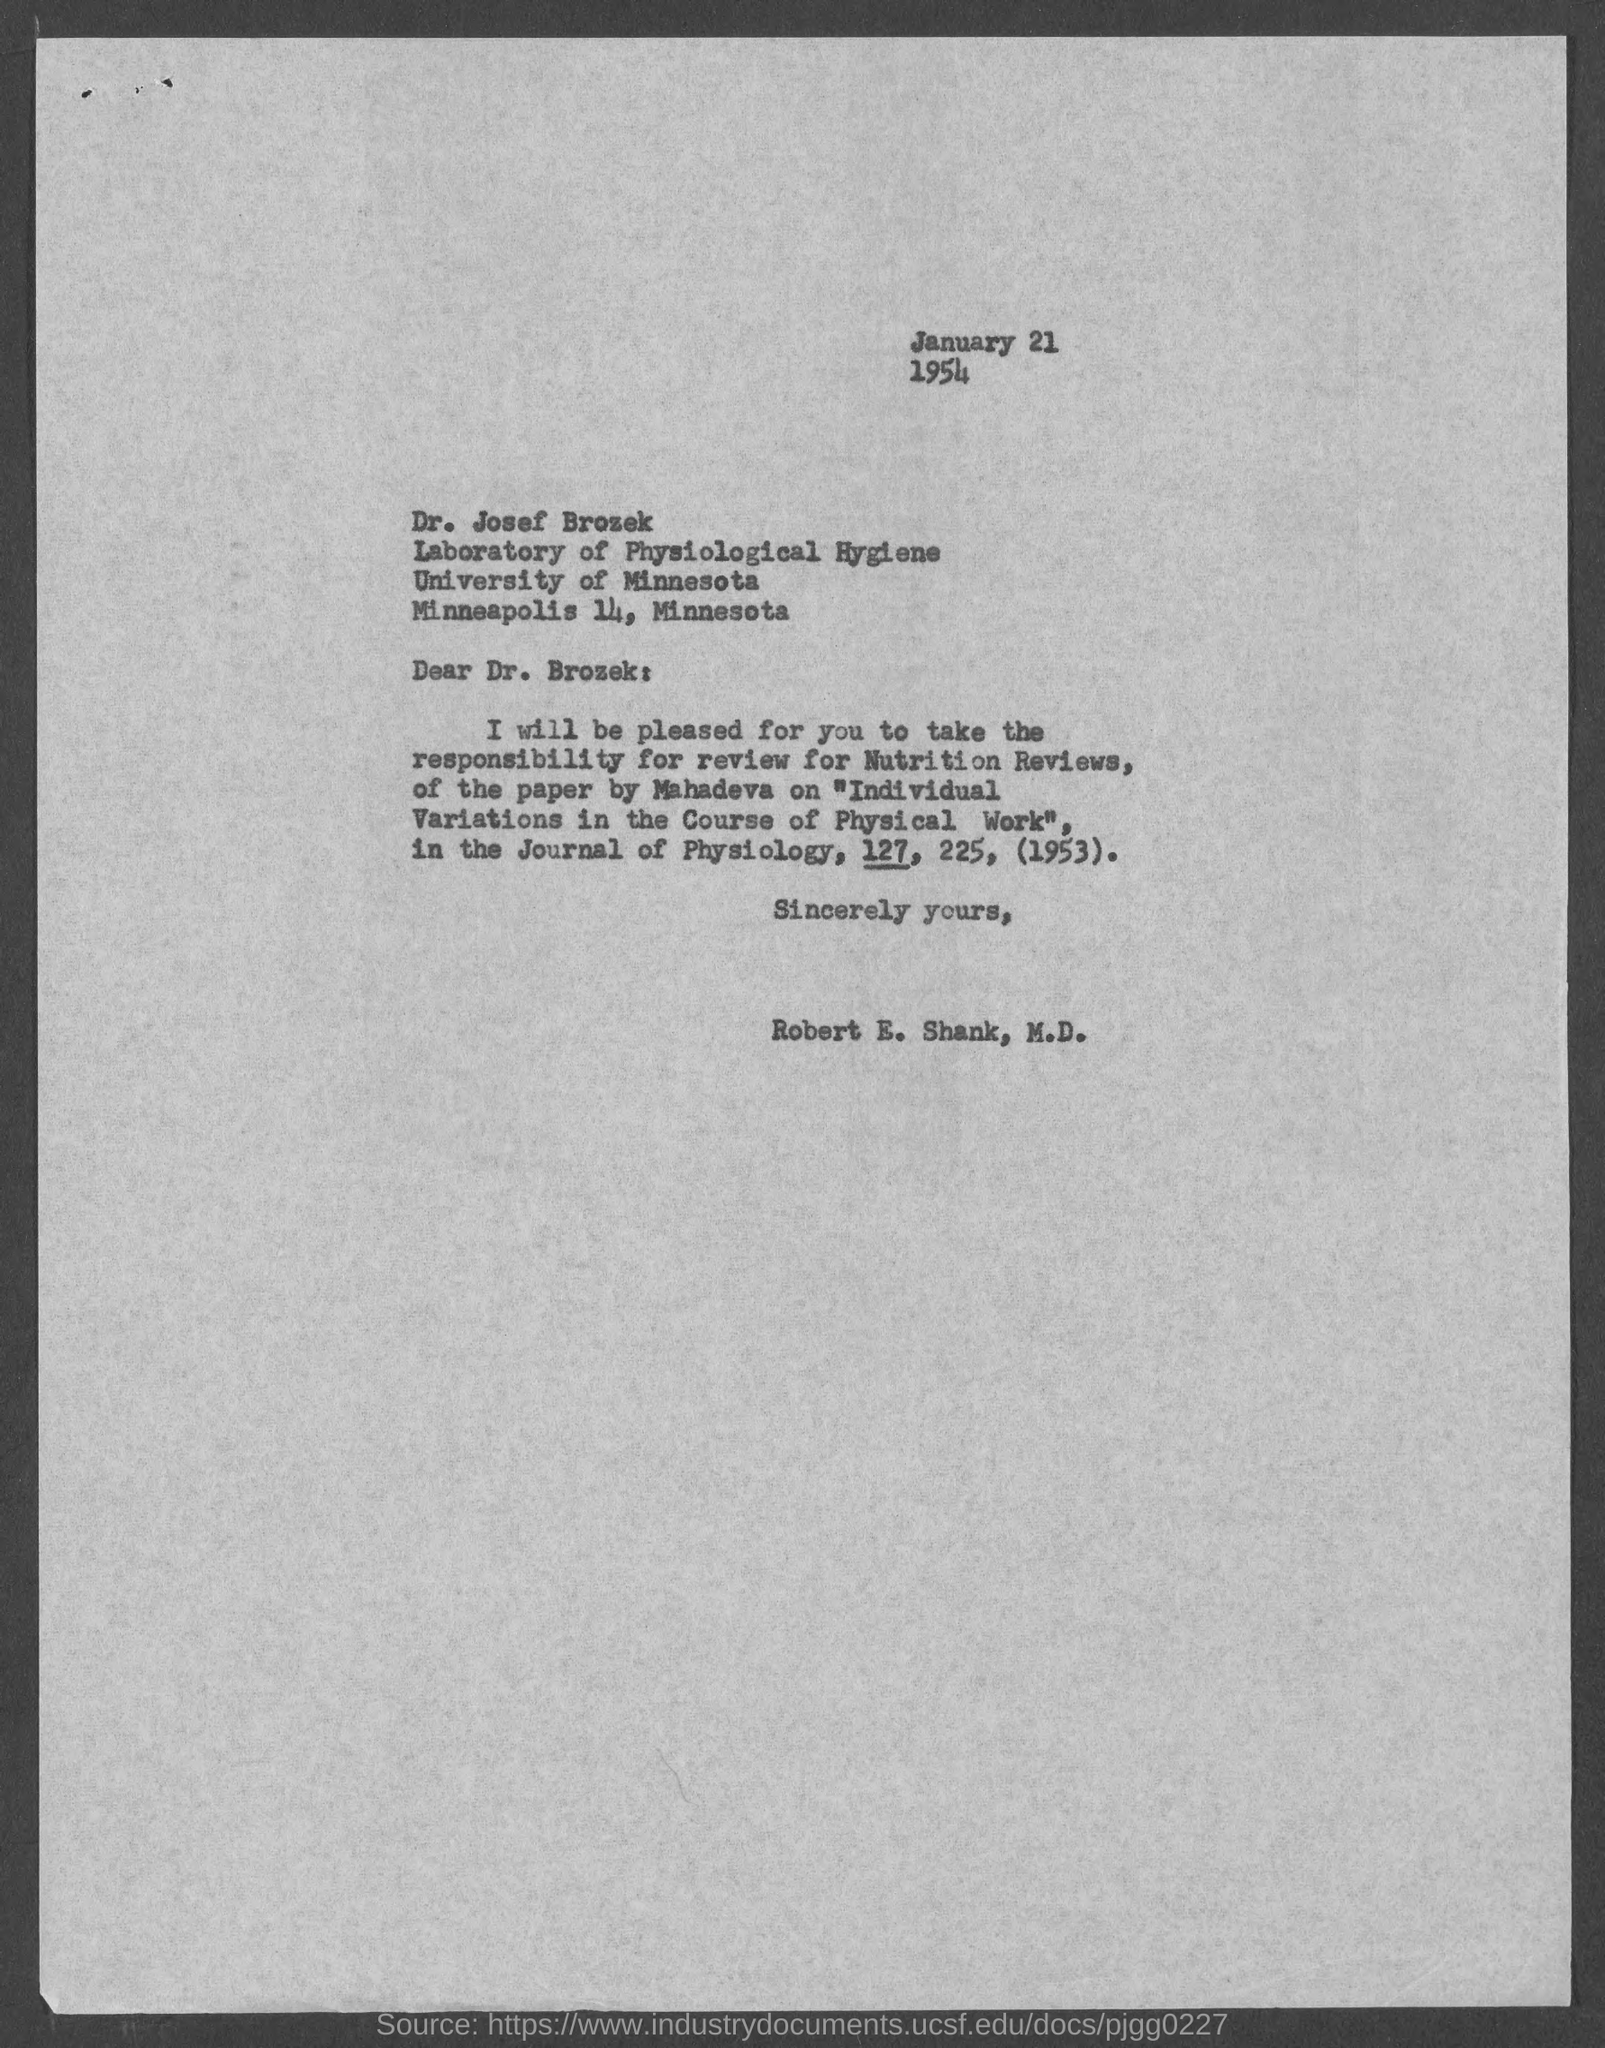Give some essential details in this illustration. The document is dated January 21.. The paper by Mahadeva is titled "Individual Variations in the Course of Physical Work. The letter is addressed to Dr. Josef Brozek. 